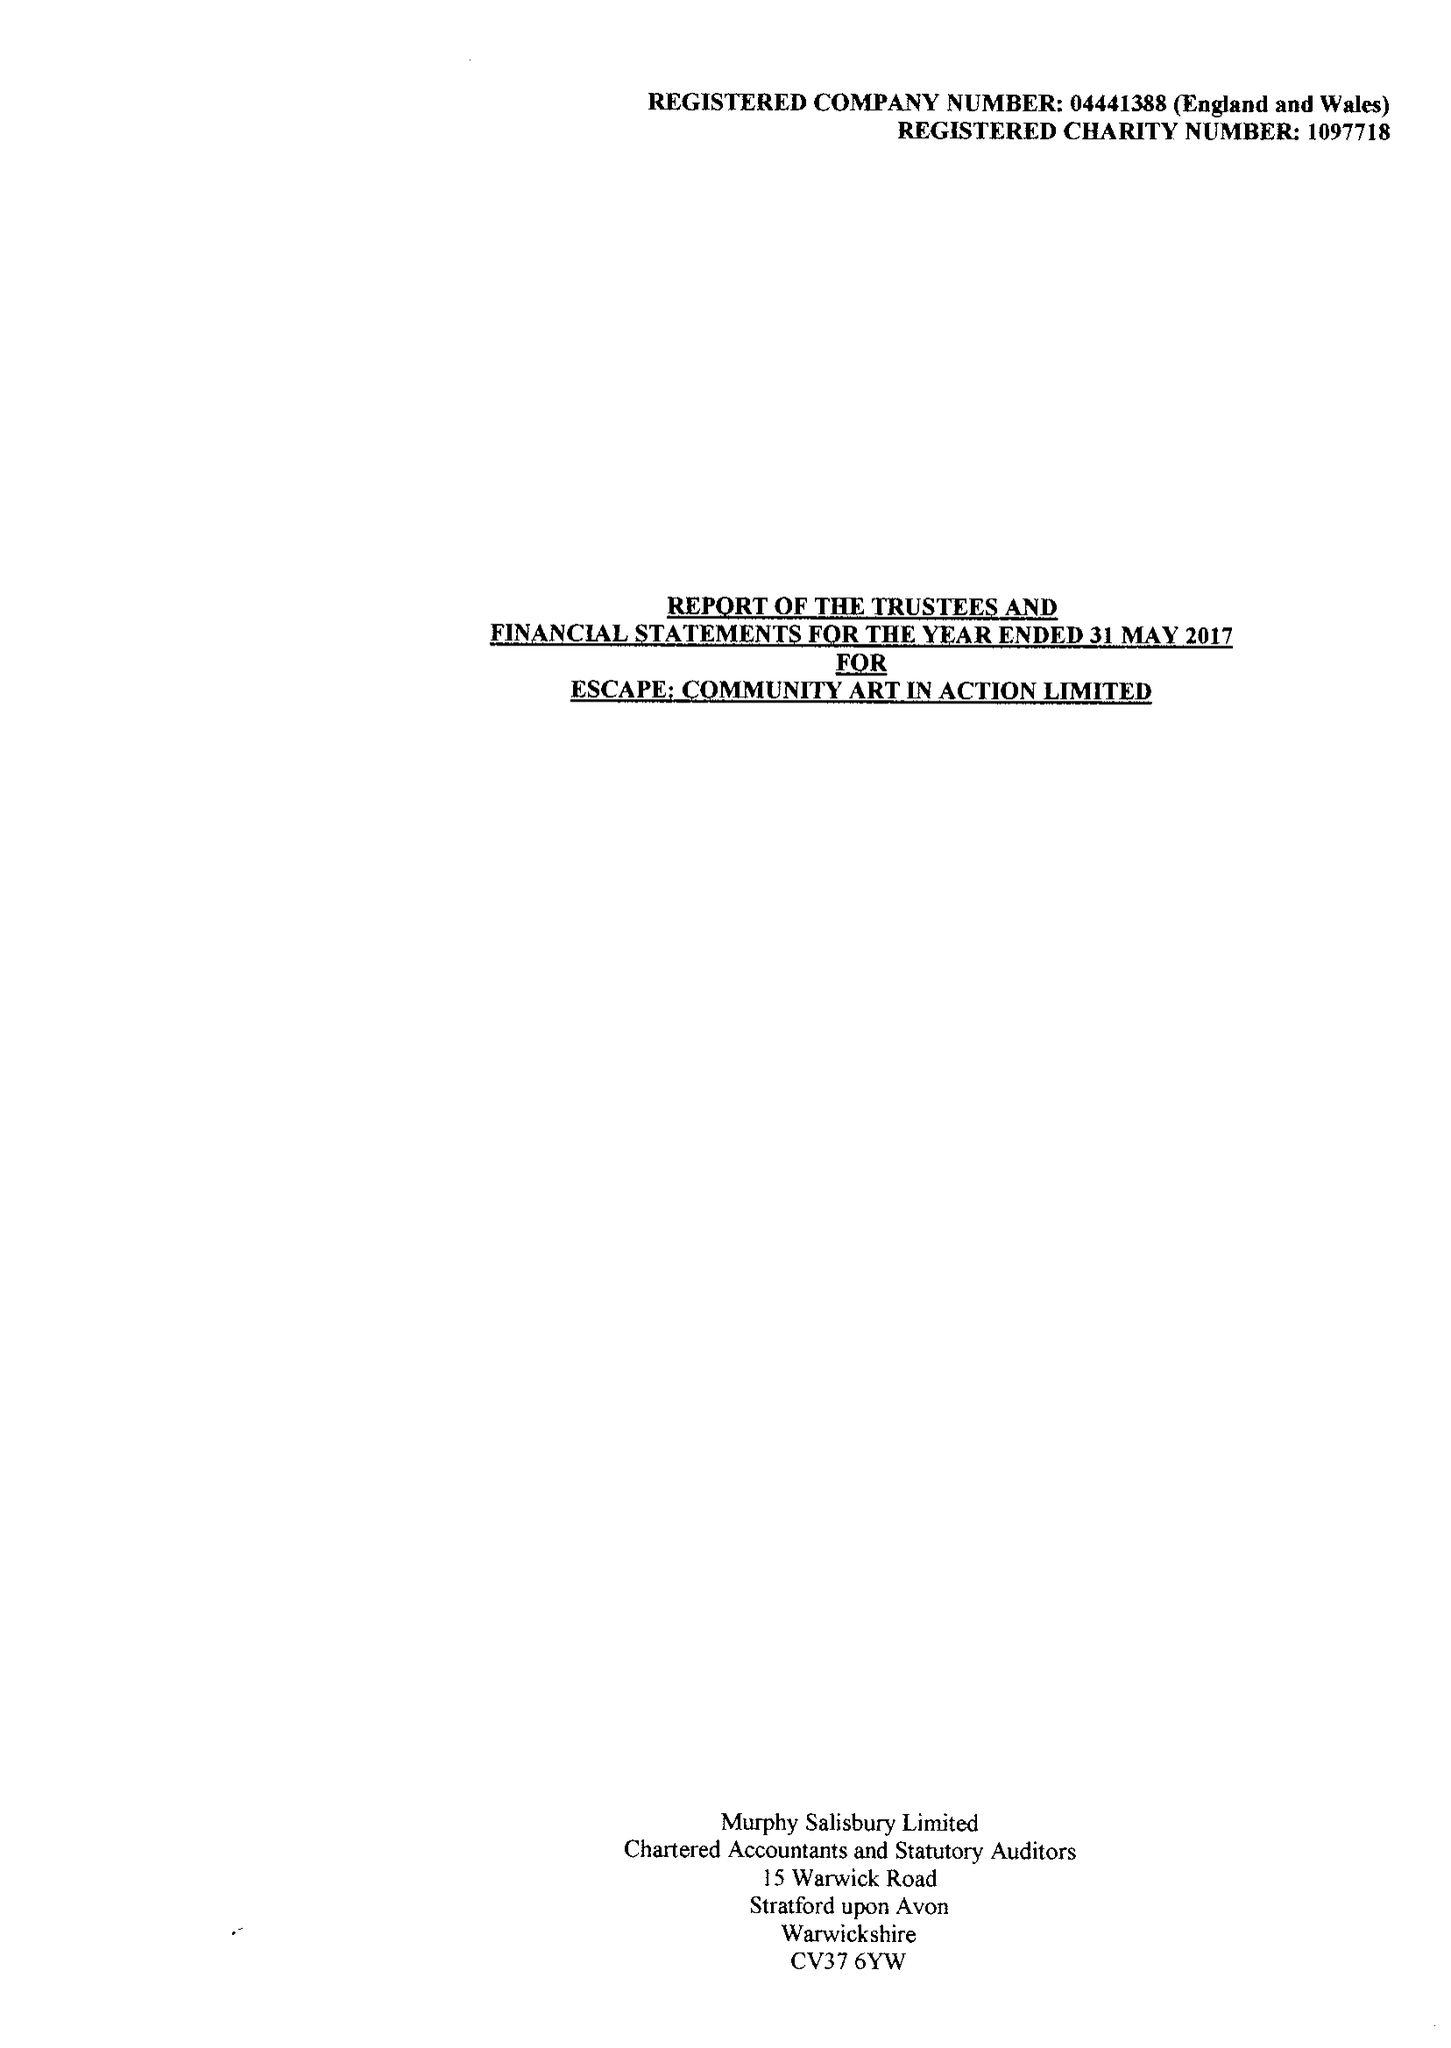What is the value for the report_date?
Answer the question using a single word or phrase. 2017-05-31 